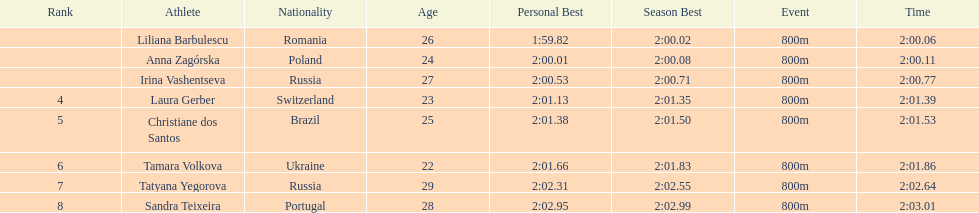What is the number of russian participants in this set of semifinals? 2. 